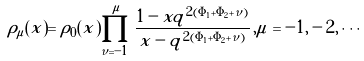Convert formula to latex. <formula><loc_0><loc_0><loc_500><loc_500>\rho _ { \mu } ( x ) = \rho _ { 0 } ( x ) \prod _ { \nu = - 1 } ^ { \mu } \frac { 1 - x q ^ { 2 ( \Phi _ { 1 } + \Phi _ { 2 } + \nu ) } } { x - q ^ { 2 ( \Phi _ { 1 } + \Phi _ { 2 } + \nu ) } } \, , \mu = - 1 , - 2 , \cdots</formula> 